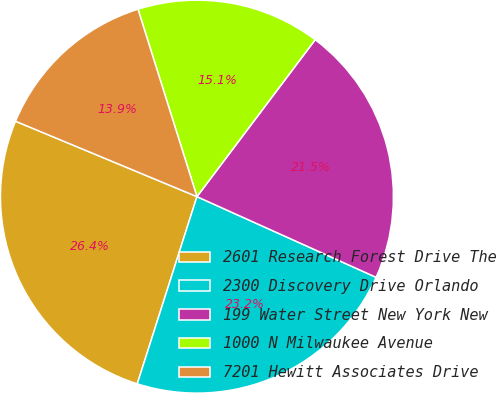Convert chart to OTSL. <chart><loc_0><loc_0><loc_500><loc_500><pie_chart><fcel>2601 Research Forest Drive The<fcel>2300 Discovery Drive Orlando<fcel>199 Water Street New York New<fcel>1000 N Milwaukee Avenue<fcel>7201 Hewitt Associates Drive<nl><fcel>26.36%<fcel>23.18%<fcel>21.46%<fcel>15.13%<fcel>13.88%<nl></chart> 